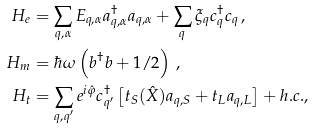<formula> <loc_0><loc_0><loc_500><loc_500>H _ { e } & = \sum _ { q , \alpha } E _ { q , \alpha } a _ { q , \alpha } ^ { \dagger } a _ { q , \alpha } + \sum _ { q } \xi _ { q } c ^ { \dagger } _ { q } c _ { q } \, , \\ H _ { m } & = \hbar { \omega } \left ( b ^ { \dag } b + 1 / 2 \right ) \, , \\ H _ { t } & = \sum _ { q , q ^ { \prime } } e ^ { i \hat { \varphi } } c _ { q ^ { \prime } } ^ { \dagger } \left [ t _ { S } ( \hat { X } ) a _ { q , S } + t _ { L } a _ { q , L } \right ] + h . c . ,</formula> 